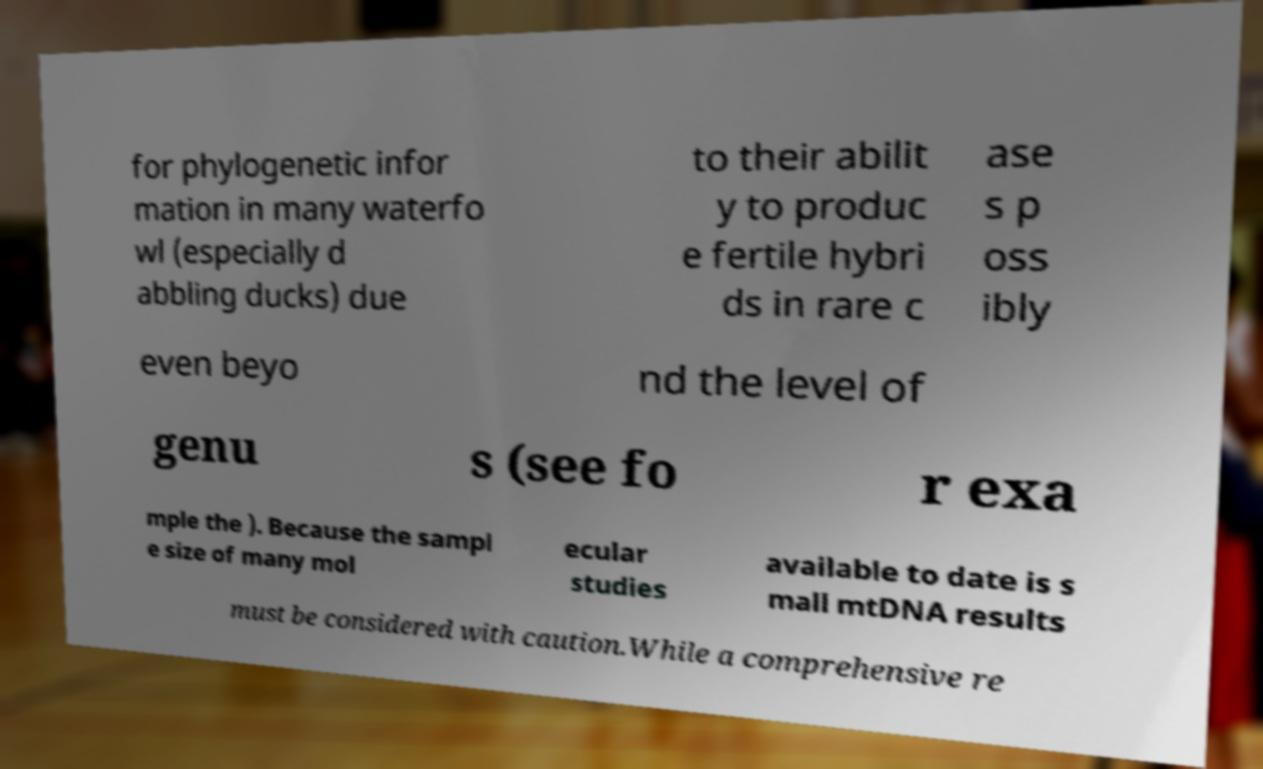Can you read and provide the text displayed in the image?This photo seems to have some interesting text. Can you extract and type it out for me? for phylogenetic infor mation in many waterfo wl (especially d abbling ducks) due to their abilit y to produc e fertile hybri ds in rare c ase s p oss ibly even beyo nd the level of genu s (see fo r exa mple the ). Because the sampl e size of many mol ecular studies available to date is s mall mtDNA results must be considered with caution.While a comprehensive re 